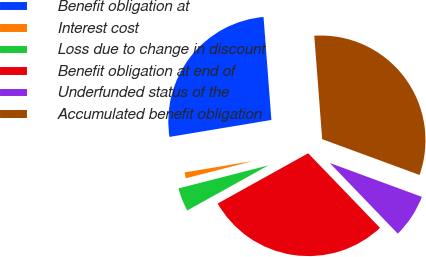Convert chart to OTSL. <chart><loc_0><loc_0><loc_500><loc_500><pie_chart><fcel>Benefit obligation at<fcel>Interest cost<fcel>Loss due to change in discount<fcel>Benefit obligation at end of<fcel>Underfunded status of the<fcel>Accumulated benefit obligation<nl><fcel>26.41%<fcel>1.37%<fcel>4.08%<fcel>29.12%<fcel>7.2%<fcel>31.82%<nl></chart> 